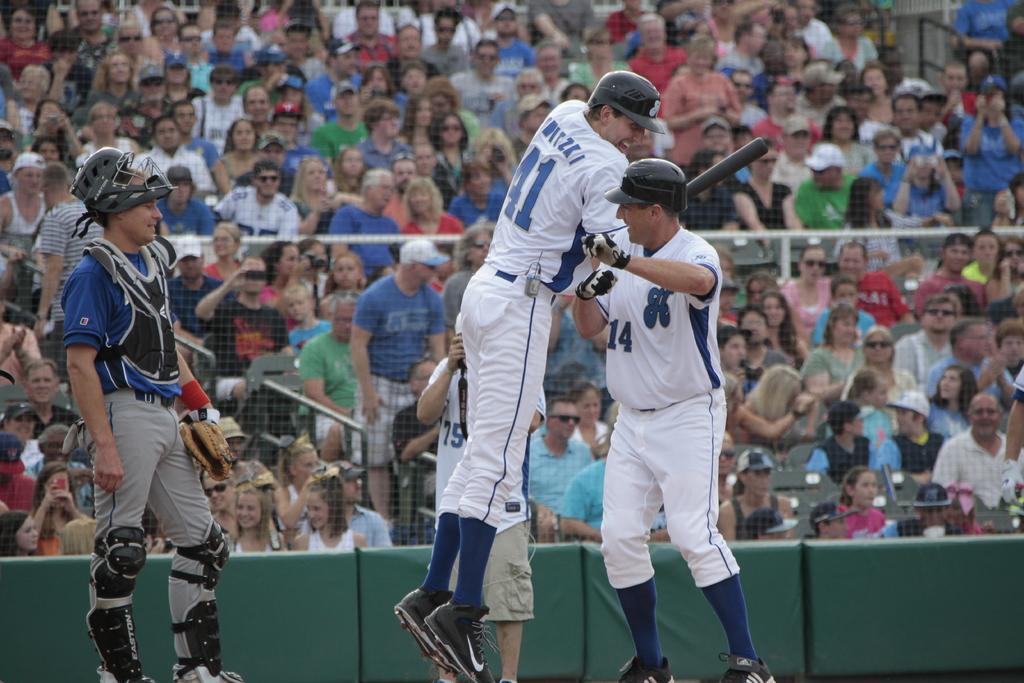How would you summarize this image in a sentence or two? This image consists of three persons playing baseball. Beside them, there is a man holding a camera. In the background, we can see a huge crowd. In the middle, there is a fencing. The three men playing baseball are wearing jerseys, helmets and a cap. 